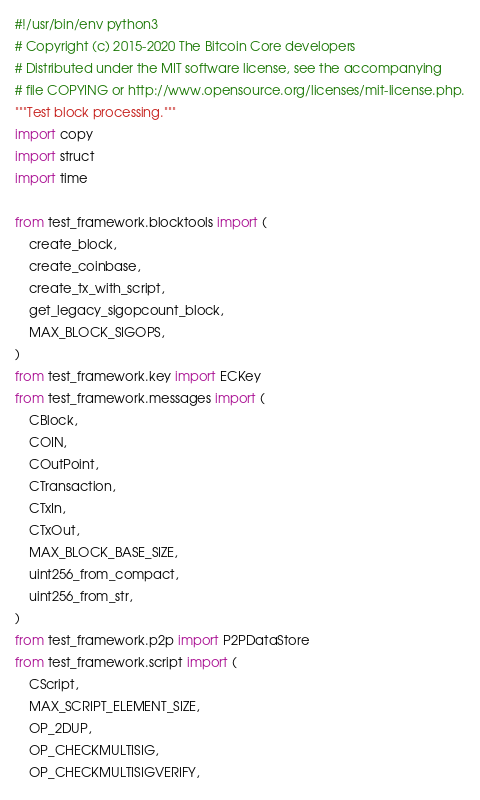Convert code to text. <code><loc_0><loc_0><loc_500><loc_500><_Python_>#!/usr/bin/env python3
# Copyright (c) 2015-2020 The Bitcoin Core developers
# Distributed under the MIT software license, see the accompanying
# file COPYING or http://www.opensource.org/licenses/mit-license.php.
"""Test block processing."""
import copy
import struct
import time

from test_framework.blocktools import (
    create_block,
    create_coinbase,
    create_tx_with_script,
    get_legacy_sigopcount_block,
    MAX_BLOCK_SIGOPS,
)
from test_framework.key import ECKey
from test_framework.messages import (
    CBlock,
    COIN,
    COutPoint,
    CTransaction,
    CTxIn,
    CTxOut,
    MAX_BLOCK_BASE_SIZE,
    uint256_from_compact,
    uint256_from_str,
)
from test_framework.p2p import P2PDataStore
from test_framework.script import (
    CScript,
    MAX_SCRIPT_ELEMENT_SIZE,
    OP_2DUP,
    OP_CHECKMULTISIG,
    OP_CHECKMULTISIGVERIFY,</code> 